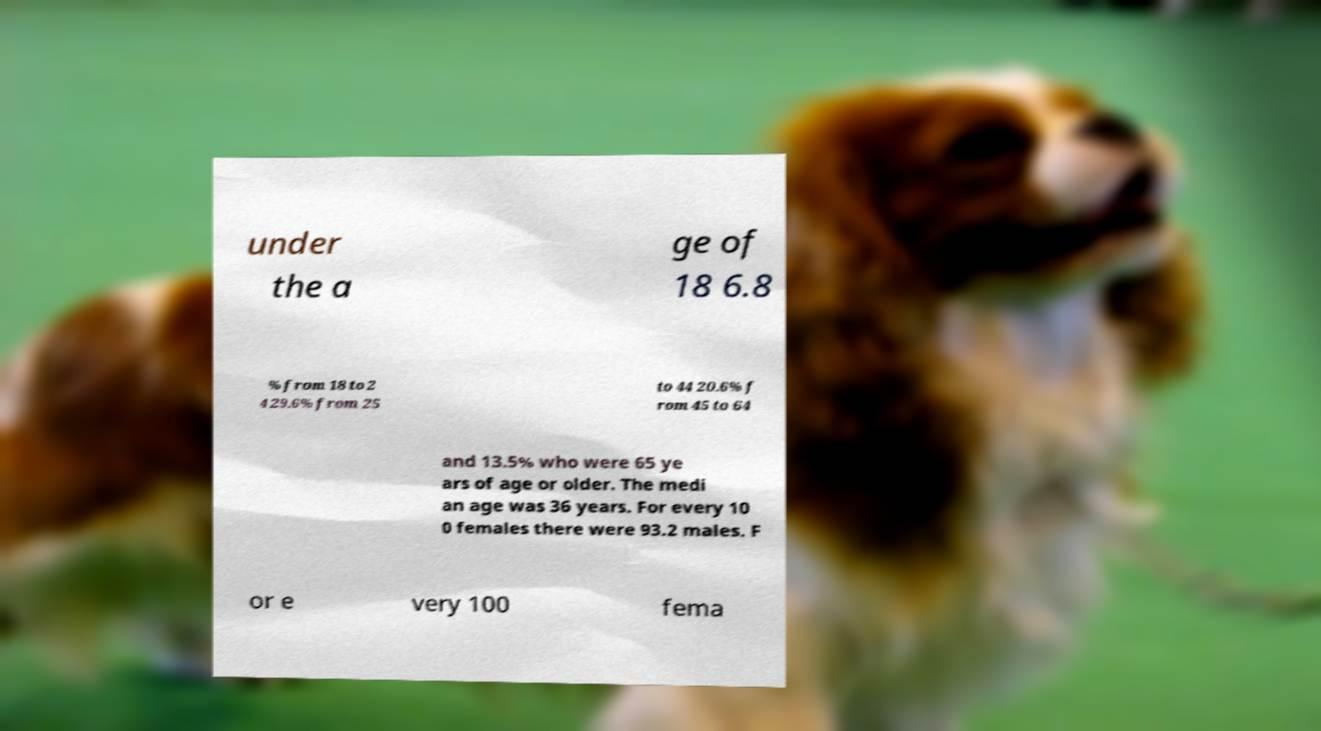For documentation purposes, I need the text within this image transcribed. Could you provide that? under the a ge of 18 6.8 % from 18 to 2 4 29.6% from 25 to 44 20.6% f rom 45 to 64 and 13.5% who were 65 ye ars of age or older. The medi an age was 36 years. For every 10 0 females there were 93.2 males. F or e very 100 fema 